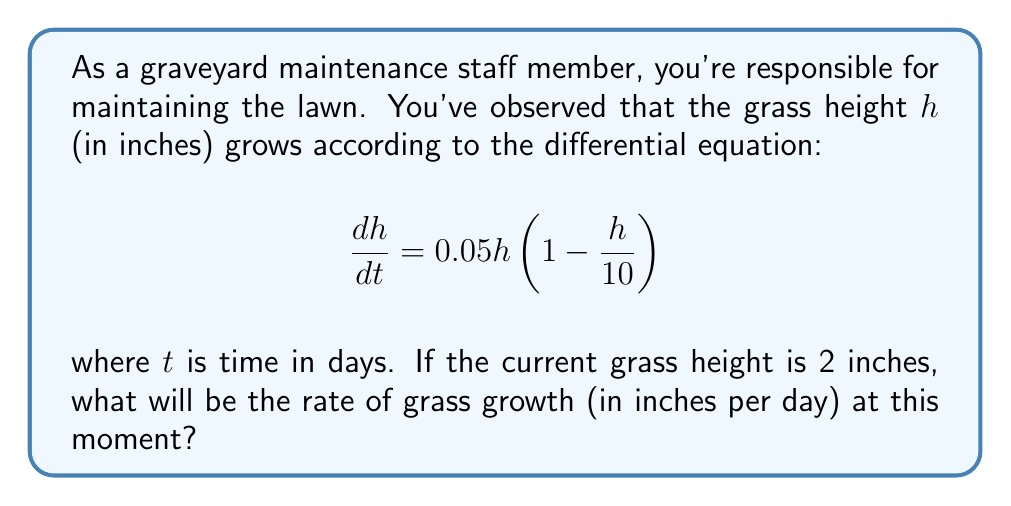What is the answer to this math problem? Let's approach this step-by-step:

1) We're given the differential equation:
   $$\frac{dh}{dt} = 0.05h(1 - \frac{h}{10})$$

2) This equation represents the rate of change of grass height ($\frac{dh}{dt}$) in terms of the current height ($h$).

3) We're told that the current grass height is 2 inches. So we need to substitute $h = 2$ into our equation.

4) Let's do this substitution:
   $$\frac{dh}{dt} = 0.05 \cdot 2 \cdot (1 - \frac{2}{10})$$

5) Simplify the fraction inside the parentheses:
   $$\frac{dh}{dt} = 0.05 \cdot 2 \cdot (1 - 0.2)$$

6) Subtract inside the parentheses:
   $$\frac{dh}{dt} = 0.05 \cdot 2 \cdot 0.8$$

7) Multiply:
   $$\frac{dh}{dt} = 0.1 \cdot 0.8 = 0.08$$

Therefore, when the grass height is 2 inches, it will be growing at a rate of 0.08 inches per day.
Answer: 0.08 inches/day 